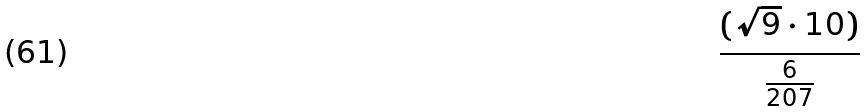Convert formula to latex. <formula><loc_0><loc_0><loc_500><loc_500>\frac { ( \sqrt { 9 } \cdot 1 0 ) } { \frac { 6 } { 2 0 7 } }</formula> 